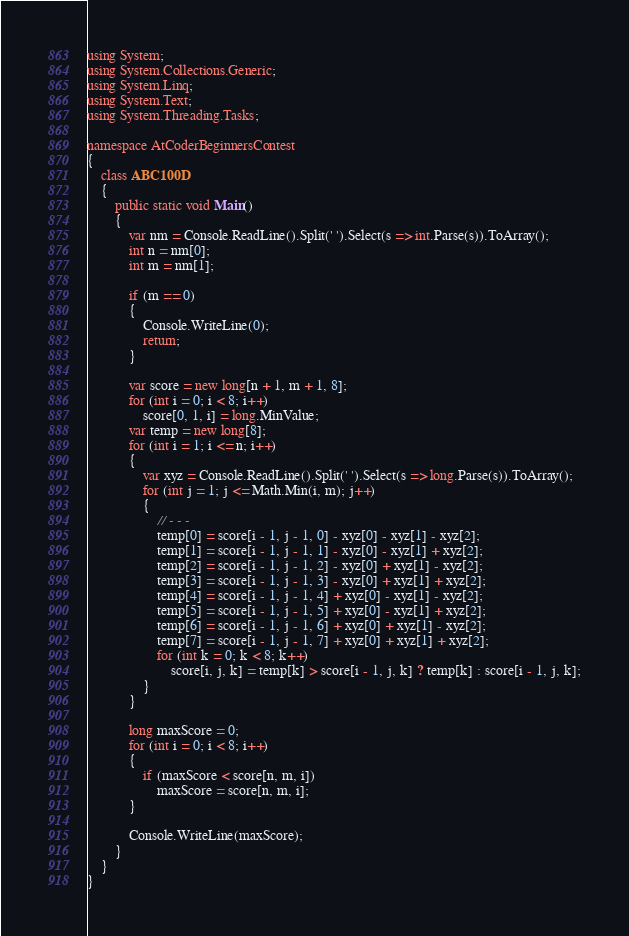Convert code to text. <code><loc_0><loc_0><loc_500><loc_500><_C#_>using System;
using System.Collections.Generic;
using System.Linq;
using System.Text;
using System.Threading.Tasks;

namespace AtCoderBeginnersContest
{
    class ABC100D
    {
        public static void Main()
        {
            var nm = Console.ReadLine().Split(' ').Select(s => int.Parse(s)).ToArray();
            int n = nm[0];
            int m = nm[1];

            if (m == 0)
            {
                Console.WriteLine(0);
                return;
            }

            var score = new long[n + 1, m + 1, 8];
            for (int i = 0; i < 8; i++)
                score[0, 1, i] = long.MinValue;
            var temp = new long[8];
            for (int i = 1; i <= n; i++)
            {
                var xyz = Console.ReadLine().Split(' ').Select(s => long.Parse(s)).ToArray();
                for (int j = 1; j <= Math.Min(i, m); j++)
                {
                    // - - -
                    temp[0] = score[i - 1, j - 1, 0] - xyz[0] - xyz[1] - xyz[2];
                    temp[1] = score[i - 1, j - 1, 1] - xyz[0] - xyz[1] + xyz[2];
                    temp[2] = score[i - 1, j - 1, 2] - xyz[0] + xyz[1] - xyz[2];
                    temp[3] = score[i - 1, j - 1, 3] - xyz[0] + xyz[1] + xyz[2];
                    temp[4] = score[i - 1, j - 1, 4] + xyz[0] - xyz[1] - xyz[2];
                    temp[5] = score[i - 1, j - 1, 5] + xyz[0] - xyz[1] + xyz[2];
                    temp[6] = score[i - 1, j - 1, 6] + xyz[0] + xyz[1] - xyz[2];
                    temp[7] = score[i - 1, j - 1, 7] + xyz[0] + xyz[1] + xyz[2];
                    for (int k = 0; k < 8; k++)
                        score[i, j, k] = temp[k] > score[i - 1, j, k] ? temp[k] : score[i - 1, j, k];
                }
            }

            long maxScore = 0;
            for (int i = 0; i < 8; i++)
            {
                if (maxScore < score[n, m, i])
                    maxScore = score[n, m, i];
            }

            Console.WriteLine(maxScore);
        }
    }
}
</code> 